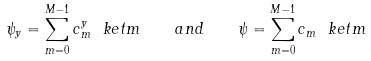Convert formula to latex. <formula><loc_0><loc_0><loc_500><loc_500>\psi _ { y } = \sum _ { m = 0 } ^ { M - 1 } c ^ { y } _ { m } \ k e t { m } \quad a n d \quad \psi = \sum _ { m = 0 } ^ { M - 1 } c _ { m } \ k e t { m }</formula> 